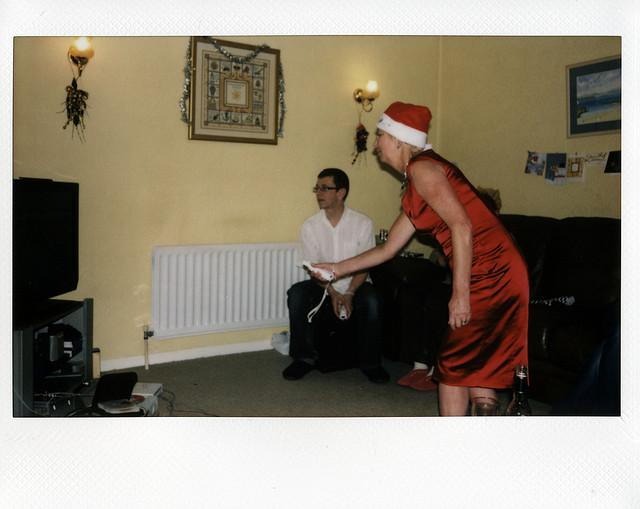What gift did the woman seen here get for Christmas?

Choices:
A) white dress
B) wii
C) cook book
D) santa hat wii 